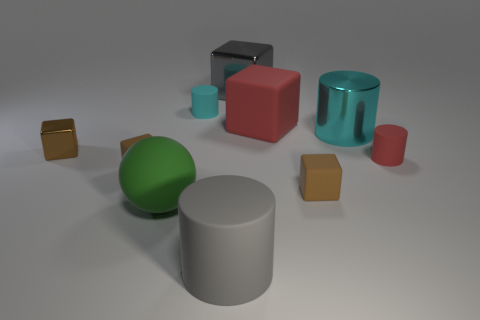Subtract all brown blocks. How many were subtracted if there are1brown blocks left? 2 Subtract all big gray cylinders. How many cylinders are left? 3 Subtract all gray cylinders. How many brown blocks are left? 3 Subtract all cyan cylinders. How many cylinders are left? 2 Subtract 1 cylinders. How many cylinders are left? 3 Subtract all spheres. How many objects are left? 9 Add 3 cyan rubber objects. How many cyan rubber objects are left? 4 Add 8 large gray blocks. How many large gray blocks exist? 9 Subtract 0 red spheres. How many objects are left? 10 Subtract all green cylinders. Subtract all brown blocks. How many cylinders are left? 4 